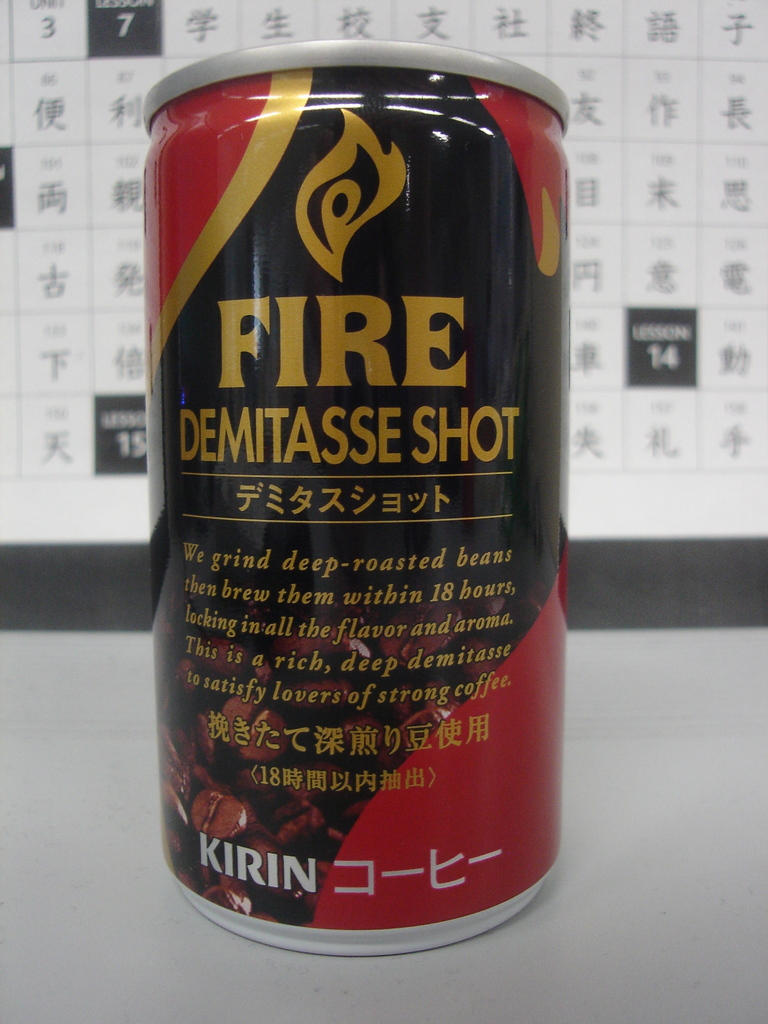What does the term 'demitasse' imply about the product? The term 'demitasse' refers to a small cup of coffee, often stronger and more concentrated than regular servings. This implies that the Kirin Fire Demitasse Shot delivers a concentrated, strong coffee flavor in a small, manageable portion appropriate for those seeking a quick, intense coffee experience. 